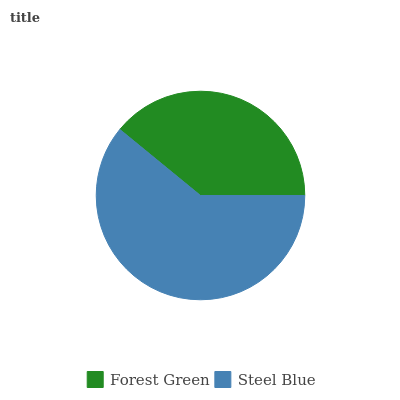Is Forest Green the minimum?
Answer yes or no. Yes. Is Steel Blue the maximum?
Answer yes or no. Yes. Is Steel Blue the minimum?
Answer yes or no. No. Is Steel Blue greater than Forest Green?
Answer yes or no. Yes. Is Forest Green less than Steel Blue?
Answer yes or no. Yes. Is Forest Green greater than Steel Blue?
Answer yes or no. No. Is Steel Blue less than Forest Green?
Answer yes or no. No. Is Steel Blue the high median?
Answer yes or no. Yes. Is Forest Green the low median?
Answer yes or no. Yes. Is Forest Green the high median?
Answer yes or no. No. Is Steel Blue the low median?
Answer yes or no. No. 